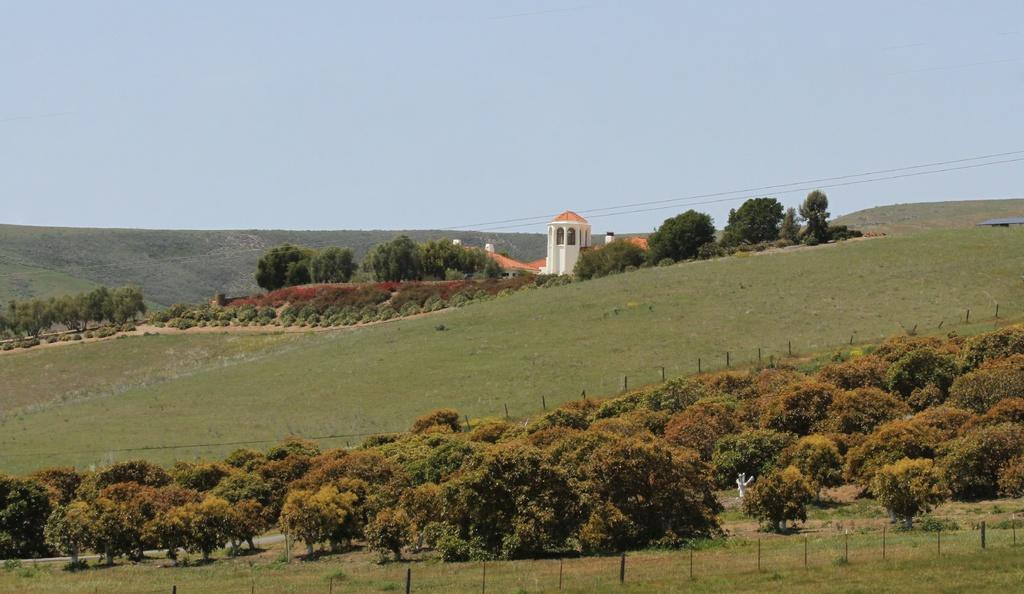What type of ground is visible in the image? The ground with grass is visible in the image. What type of vegetation can be seen in the image? Plants and trees are visible in the image. What type of structures are present in the image? There are buildings in the image. What type of vertical structures are present in the image? Poles are present in the image. What part of the natural environment is visible in the image? The sky is visible in the image. Can you tell me how many grandmothers are sitting on the grass in the image? There are no grandmothers present in the image; it features plants, trees, buildings, poles, and the sky. What type of partner is visible in the image? There is no partner present in the image; it features plants, trees, buildings, poles, and the sky. 